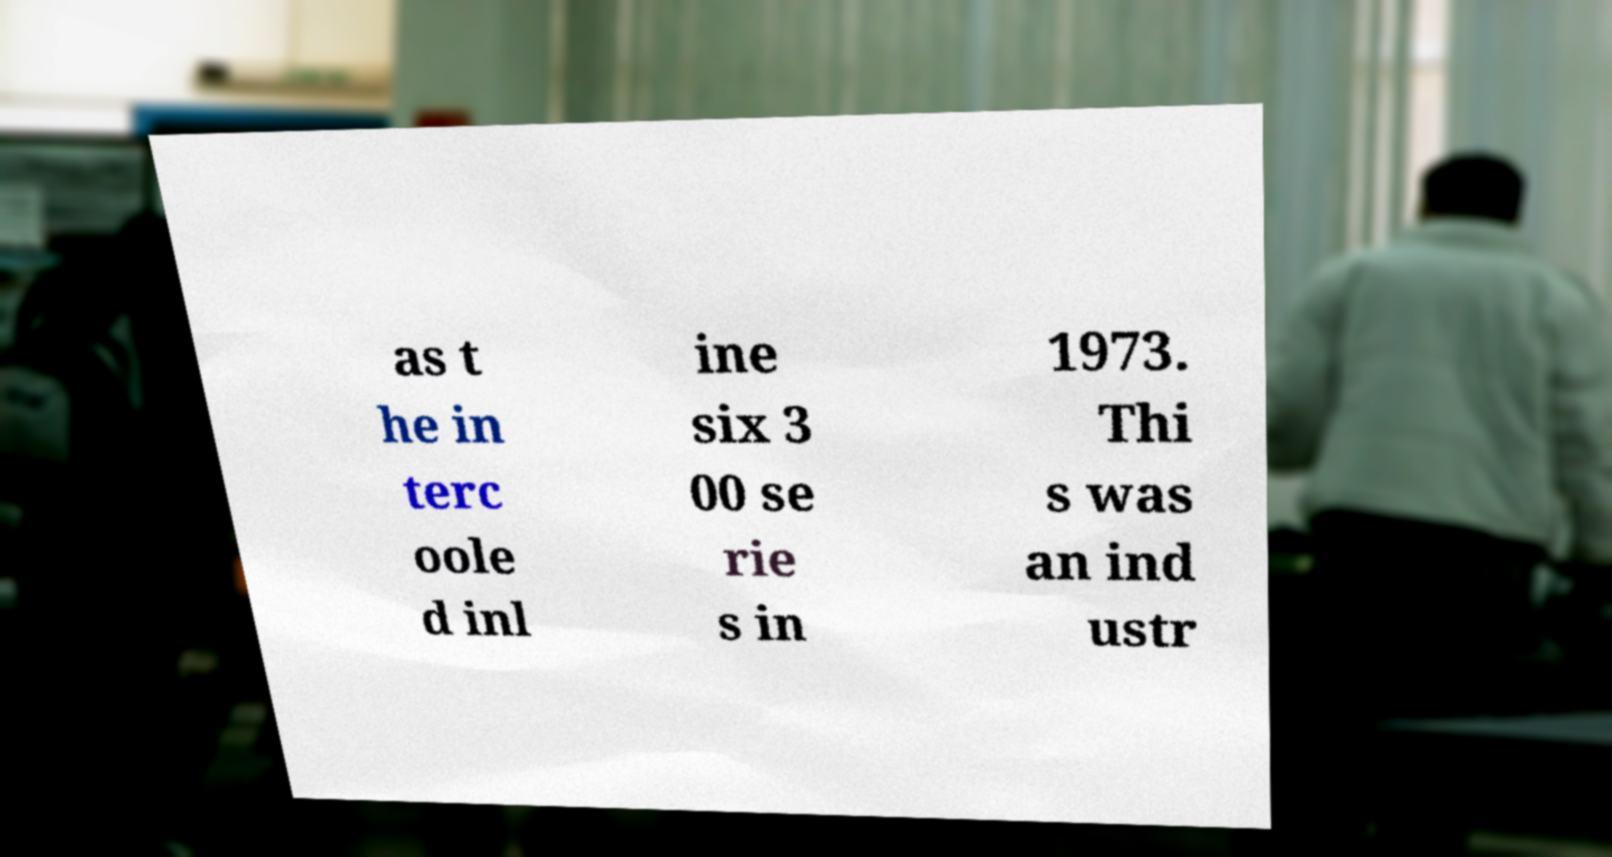For documentation purposes, I need the text within this image transcribed. Could you provide that? as t he in terc oole d inl ine six 3 00 se rie s in 1973. Thi s was an ind ustr 